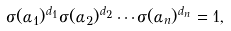Convert formula to latex. <formula><loc_0><loc_0><loc_500><loc_500>\sigma ( \alpha _ { 1 } ) ^ { d _ { 1 } } \sigma ( \alpha _ { 2 } ) ^ { d _ { 2 } } \cdots \sigma ( \alpha _ { n } ) ^ { d _ { n } } = 1 ,</formula> 